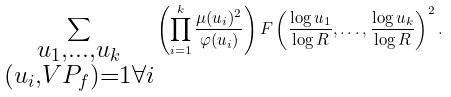<formula> <loc_0><loc_0><loc_500><loc_500>\sum _ { \substack { u _ { 1 } , \dots , u _ { k } \\ ( u _ { i } , V P _ { f } ) = 1 \forall i } } \left ( \prod _ { i = 1 } ^ { k } \frac { \mu ( u _ { i } ) ^ { 2 } } { \varphi ( u _ { i } ) } \right ) F \left ( \frac { \log u _ { 1 } } { \log R } , \dots , \frac { \log u _ { k } } { \log R } \right ) ^ { 2 } .</formula> 